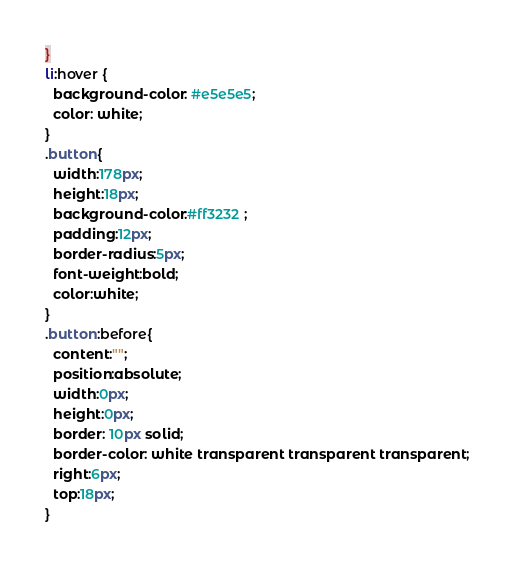<code> <loc_0><loc_0><loc_500><loc_500><_CSS_>}
li:hover {
  background-color: #e5e5e5;
  color: white;
}
.button{
  width:178px;
  height:18px;
  background-color:#ff3232 ;
  padding:12px;
  border-radius:5px;
  font-weight:bold;
  color:white;
}
.button:before{
  content:"";
  position:absolute;
  width:0px;
  height:0px;
  border: 10px solid;
  border-color: white transparent transparent transparent;
  right:6px;
  top:18px;
}</code> 